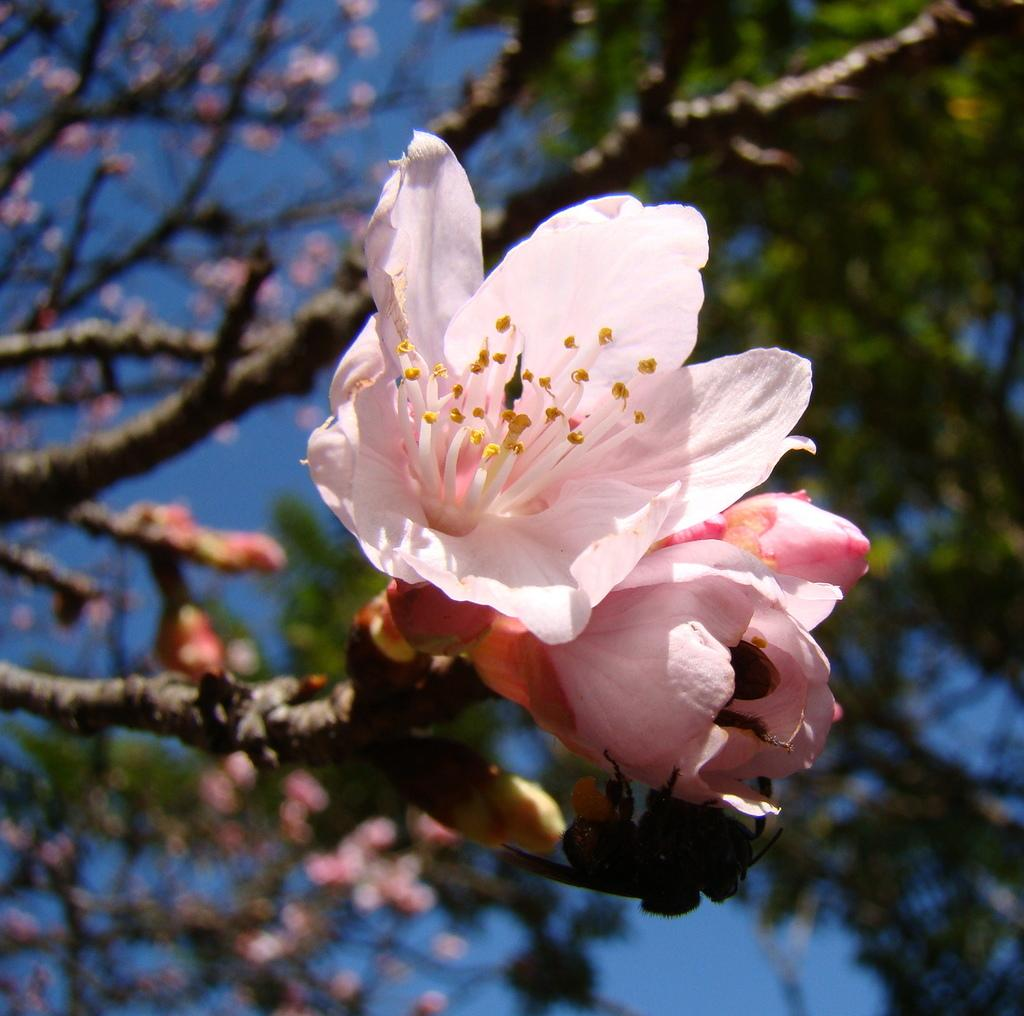What type of vegetation can be seen in the foreground of the image? There are flowers on a tree in the foreground of the image. What can be seen in the background of the image? There are trees and the sky visible in the background of the image. What things are quivering in the image? There are no things quivering in the image. Can you describe the action of smashing in the image? There is no action of smashing depicted in the image. 